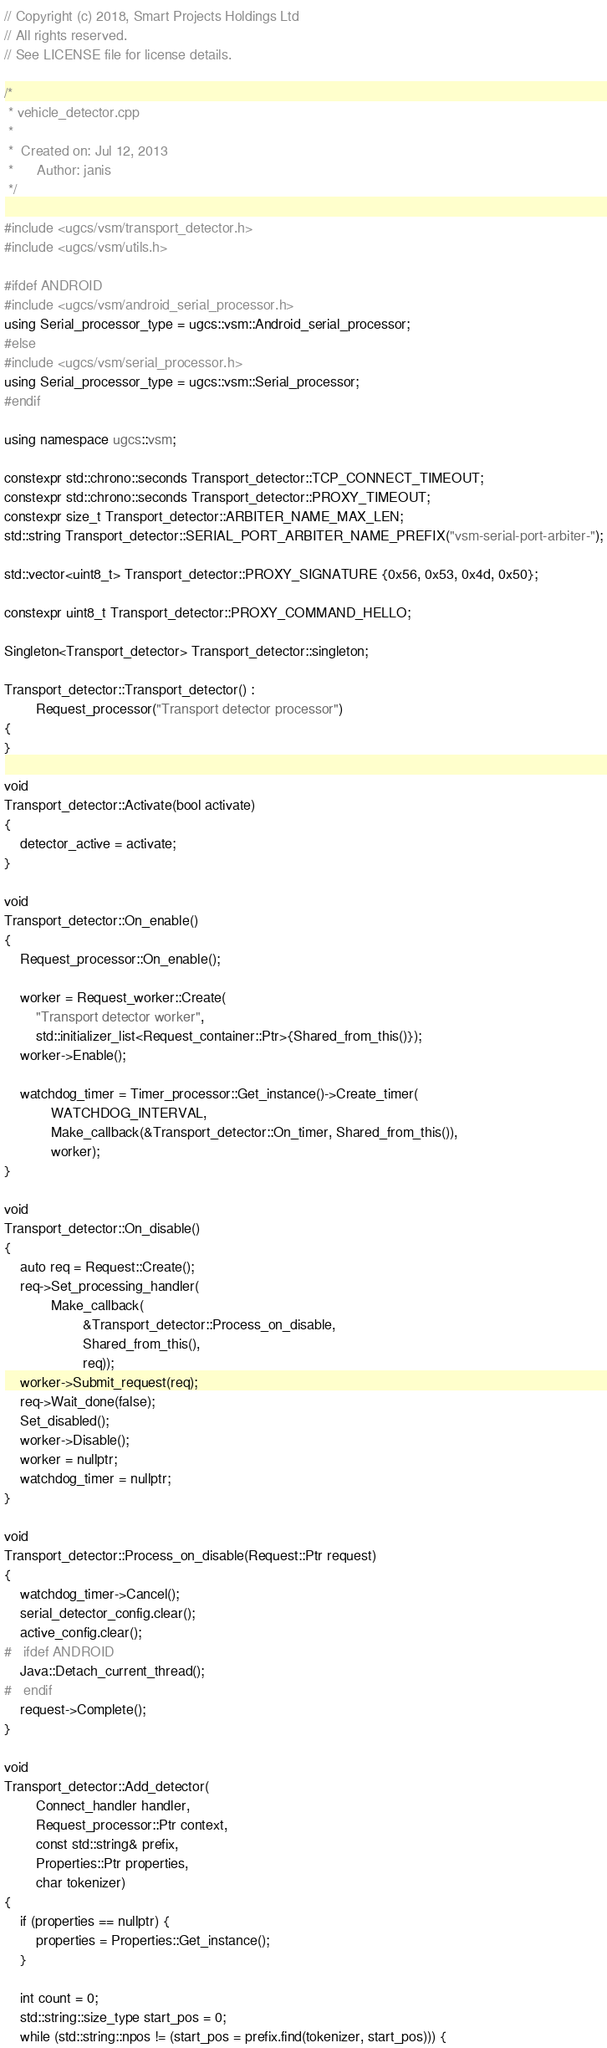<code> <loc_0><loc_0><loc_500><loc_500><_C++_>// Copyright (c) 2018, Smart Projects Holdings Ltd
// All rights reserved.
// See LICENSE file for license details.

/*
 * vehicle_detector.cpp
 *
 *  Created on: Jul 12, 2013
 *      Author: janis
 */

#include <ugcs/vsm/transport_detector.h>
#include <ugcs/vsm/utils.h>

#ifdef ANDROID
#include <ugcs/vsm/android_serial_processor.h>
using Serial_processor_type = ugcs::vsm::Android_serial_processor;
#else
#include <ugcs/vsm/serial_processor.h>
using Serial_processor_type = ugcs::vsm::Serial_processor;
#endif

using namespace ugcs::vsm;

constexpr std::chrono::seconds Transport_detector::TCP_CONNECT_TIMEOUT;
constexpr std::chrono::seconds Transport_detector::PROXY_TIMEOUT;
constexpr size_t Transport_detector::ARBITER_NAME_MAX_LEN;
std::string Transport_detector::SERIAL_PORT_ARBITER_NAME_PREFIX("vsm-serial-port-arbiter-");

std::vector<uint8_t> Transport_detector::PROXY_SIGNATURE {0x56, 0x53, 0x4d, 0x50};

constexpr uint8_t Transport_detector::PROXY_COMMAND_HELLO;

Singleton<Transport_detector> Transport_detector::singleton;

Transport_detector::Transport_detector() :
        Request_processor("Transport detector processor")
{
}

void
Transport_detector::Activate(bool activate)
{
    detector_active = activate;
}

void
Transport_detector::On_enable()
{
    Request_processor::On_enable();

    worker = Request_worker::Create(
        "Transport detector worker",
        std::initializer_list<Request_container::Ptr>{Shared_from_this()});
    worker->Enable();

    watchdog_timer = Timer_processor::Get_instance()->Create_timer(
            WATCHDOG_INTERVAL,
            Make_callback(&Transport_detector::On_timer, Shared_from_this()),
            worker);
}

void
Transport_detector::On_disable()
{
    auto req = Request::Create();
    req->Set_processing_handler(
            Make_callback(
                    &Transport_detector::Process_on_disable,
                    Shared_from_this(),
                    req));
    worker->Submit_request(req);
    req->Wait_done(false);
    Set_disabled();
    worker->Disable();
    worker = nullptr;
    watchdog_timer = nullptr;
}

void
Transport_detector::Process_on_disable(Request::Ptr request)
{
    watchdog_timer->Cancel();
    serial_detector_config.clear();
    active_config.clear();
#   ifdef ANDROID
    Java::Detach_current_thread();
#   endif
    request->Complete();
}

void
Transport_detector::Add_detector(
        Connect_handler handler,
        Request_processor::Ptr context,
        const std::string& prefix,
        Properties::Ptr properties,
        char tokenizer)
{
    if (properties == nullptr) {
        properties = Properties::Get_instance();
    }

    int count = 0;
    std::string::size_type start_pos = 0;
    while (std::string::npos != (start_pos = prefix.find(tokenizer, start_pos))) {</code> 